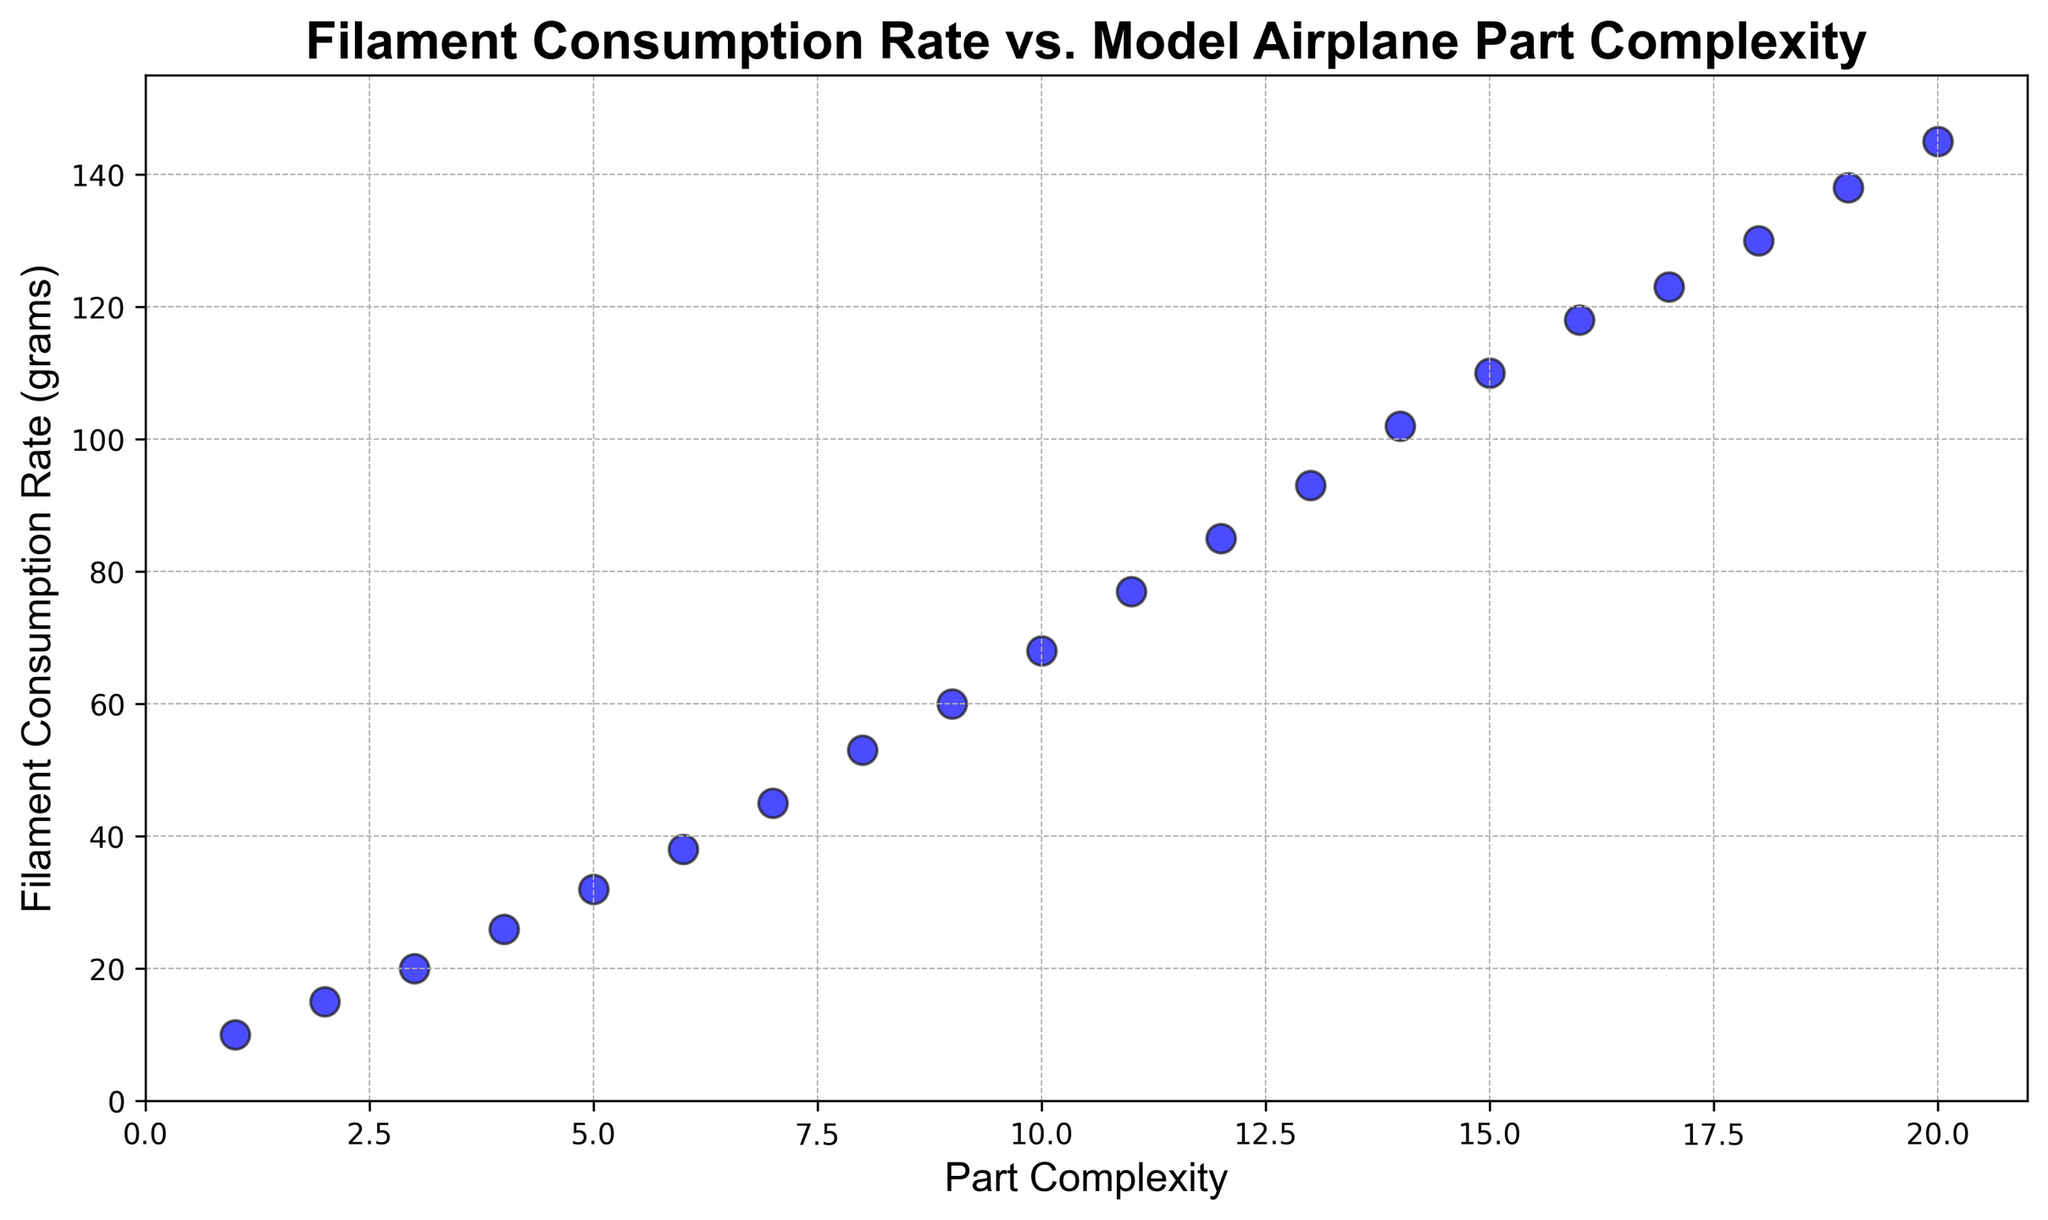What is the filament consumption rate for a part complexity of 10? To find the filament consumption rate at a part complexity of 10, locate the point on the x-axis labeled "10" and then check its corresponding value on the y-axis.
Answer: 68 How does the filament consumption rate change between part complexity 5 and 10? Locate the filament consumption rate at part complexity 5 (32) and 10 (68). Calculate the change by subtracting the rate at complexity 5 from the rate at complexity 10: 68 - 32 = 36.
Answer: 36 What part complexity has the highest filament consumption rate, and what is that rate? Find the highest point on the y-axis (Filament Consumption Rate), which is 145, then check the corresponding x-axis (Part Complexity) value.
Answer: 20 and 145 Which part complexity has a filament consumption rate of approximately 85 grams? Locate the value of 85 on the y-axis (Filament Consumption Rate) and find its corresponding x-axis (Part Complexity) value.
Answer: 12 Are there any part complexities where the filament consumption rate increases by an equal amount consecutively? If so, identify them. Check for consistent increments in Filament Consumption Rate between consecutive part complexities. For example, the rate increases by 8 grams for complexities 15 to 16 (110 to 118) and 16 to 17 (118 to 123). However, not all increments are consistent.
Answer: No, the increments are not consistent Compare the filament consumption rates between part complexity 8 and 14. Which one is higher and by how much? Find the filament consumption rates for complexities 8 (53) and 14 (102). Calculate the difference (102 - 53 = 49).
Answer: Complexity 14 is higher by 49 grams If the filament consumption rate increases linearly, what can be estimated as the filament consumption rate for a part complexity of 21? Observing the trend line, the rate increases roughly by 7-8 grams for each unit increase in part complexity. For complexity 20, the rate is 145. Extrapolating linearly, the rate for complexity 21 would be around 145 + 7 or 145 + 8.
Answer: Approximately 152-153 grams What is the range of filament consumption rates shown in the plot? To calculate the range, subtract the smallest consumption rate (10 at complexity 1) from the largest (145 at complexity 20).
Answer: 135 Does the scatter plot suggest a linear relationship between part complexity and filament consumption rate? Examine the plotted points; they appear to form a straight line from the bottom-left to the top-right corner, indicating a linear relationship.
Answer: Yes What is the average filament consumption rate for part complexities from 1 to 5? Sum the filament consumption rates at complexities 1 (10), 2 (15), 3 (20), 4 (26), and 5 (32), then divide by 5: (10 + 15 + 20 + 26 + 32) / 5 = 103 / 5.
Answer: 20.6 